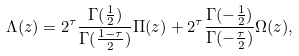Convert formula to latex. <formula><loc_0><loc_0><loc_500><loc_500>\Lambda ( z ) = 2 ^ { \tau } \frac { \Gamma ( \frac { 1 } { 2 } ) } { \Gamma ( \frac { 1 - \tau } { 2 } ) } \Pi ( z ) + 2 ^ { \tau } \frac { \Gamma ( - \frac { 1 } { 2 } ) } { \Gamma ( - \frac { \tau } { 2 } ) } \Omega ( z ) ,</formula> 